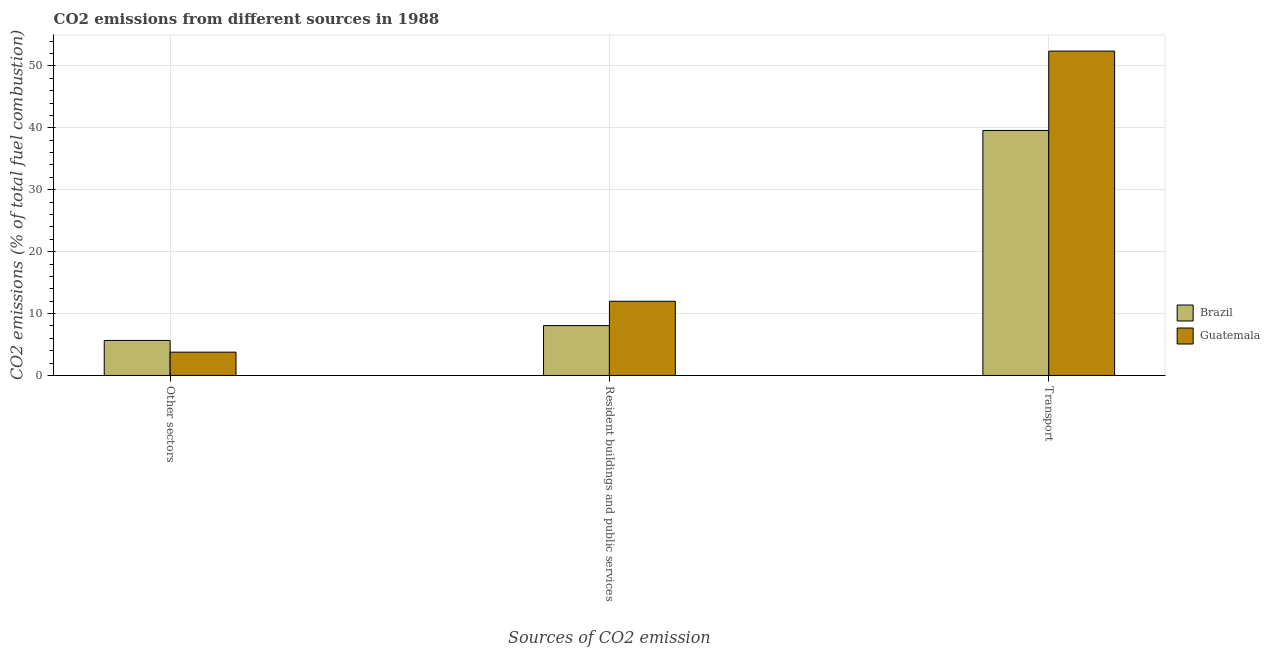How many different coloured bars are there?
Make the answer very short. 2. How many groups of bars are there?
Provide a short and direct response. 3. How many bars are there on the 2nd tick from the right?
Offer a terse response. 2. What is the label of the 2nd group of bars from the left?
Your response must be concise. Resident buildings and public services. What is the percentage of co2 emissions from other sectors in Guatemala?
Give a very brief answer. 3.77. Across all countries, what is the maximum percentage of co2 emissions from resident buildings and public services?
Offer a very short reply. 11.99. Across all countries, what is the minimum percentage of co2 emissions from transport?
Your response must be concise. 39.58. In which country was the percentage of co2 emissions from transport maximum?
Your answer should be compact. Guatemala. In which country was the percentage of co2 emissions from resident buildings and public services minimum?
Offer a very short reply. Brazil. What is the total percentage of co2 emissions from resident buildings and public services in the graph?
Ensure brevity in your answer.  20.05. What is the difference between the percentage of co2 emissions from other sectors in Brazil and that in Guatemala?
Offer a terse response. 1.89. What is the difference between the percentage of co2 emissions from other sectors in Brazil and the percentage of co2 emissions from transport in Guatemala?
Offer a terse response. -46.74. What is the average percentage of co2 emissions from transport per country?
Provide a succinct answer. 45.99. What is the difference between the percentage of co2 emissions from transport and percentage of co2 emissions from resident buildings and public services in Guatemala?
Your answer should be very brief. 40.41. In how many countries, is the percentage of co2 emissions from resident buildings and public services greater than 12 %?
Your response must be concise. 0. What is the ratio of the percentage of co2 emissions from transport in Guatemala to that in Brazil?
Your answer should be compact. 1.32. Is the difference between the percentage of co2 emissions from transport in Brazil and Guatemala greater than the difference between the percentage of co2 emissions from other sectors in Brazil and Guatemala?
Your answer should be compact. No. What is the difference between the highest and the second highest percentage of co2 emissions from resident buildings and public services?
Make the answer very short. 3.93. What is the difference between the highest and the lowest percentage of co2 emissions from other sectors?
Make the answer very short. 1.89. What does the 1st bar from the left in Other sectors represents?
Offer a very short reply. Brazil. What does the 1st bar from the right in Transport represents?
Offer a very short reply. Guatemala. How many bars are there?
Your answer should be compact. 6. Are all the bars in the graph horizontal?
Your answer should be very brief. No. How many countries are there in the graph?
Keep it short and to the point. 2. Are the values on the major ticks of Y-axis written in scientific E-notation?
Give a very brief answer. No. Does the graph contain grids?
Offer a terse response. Yes. What is the title of the graph?
Provide a short and direct response. CO2 emissions from different sources in 1988. Does "Seychelles" appear as one of the legend labels in the graph?
Provide a short and direct response. No. What is the label or title of the X-axis?
Make the answer very short. Sources of CO2 emission. What is the label or title of the Y-axis?
Your answer should be very brief. CO2 emissions (% of total fuel combustion). What is the CO2 emissions (% of total fuel combustion) in Brazil in Other sectors?
Give a very brief answer. 5.66. What is the CO2 emissions (% of total fuel combustion) of Guatemala in Other sectors?
Your response must be concise. 3.77. What is the CO2 emissions (% of total fuel combustion) of Brazil in Resident buildings and public services?
Make the answer very short. 8.06. What is the CO2 emissions (% of total fuel combustion) in Guatemala in Resident buildings and public services?
Your answer should be very brief. 11.99. What is the CO2 emissions (% of total fuel combustion) in Brazil in Transport?
Offer a very short reply. 39.58. What is the CO2 emissions (% of total fuel combustion) of Guatemala in Transport?
Offer a very short reply. 52.4. Across all Sources of CO2 emission, what is the maximum CO2 emissions (% of total fuel combustion) in Brazil?
Your answer should be very brief. 39.58. Across all Sources of CO2 emission, what is the maximum CO2 emissions (% of total fuel combustion) of Guatemala?
Provide a succinct answer. 52.4. Across all Sources of CO2 emission, what is the minimum CO2 emissions (% of total fuel combustion) of Brazil?
Offer a terse response. 5.66. Across all Sources of CO2 emission, what is the minimum CO2 emissions (% of total fuel combustion) of Guatemala?
Offer a very short reply. 3.77. What is the total CO2 emissions (% of total fuel combustion) of Brazil in the graph?
Your response must be concise. 53.3. What is the total CO2 emissions (% of total fuel combustion) in Guatemala in the graph?
Make the answer very short. 68.15. What is the difference between the CO2 emissions (% of total fuel combustion) of Brazil in Other sectors and that in Resident buildings and public services?
Keep it short and to the point. -2.4. What is the difference between the CO2 emissions (% of total fuel combustion) of Guatemala in Other sectors and that in Resident buildings and public services?
Your answer should be compact. -8.22. What is the difference between the CO2 emissions (% of total fuel combustion) of Brazil in Other sectors and that in Transport?
Your response must be concise. -33.92. What is the difference between the CO2 emissions (% of total fuel combustion) in Guatemala in Other sectors and that in Transport?
Offer a very short reply. -48.63. What is the difference between the CO2 emissions (% of total fuel combustion) in Brazil in Resident buildings and public services and that in Transport?
Make the answer very short. -31.52. What is the difference between the CO2 emissions (% of total fuel combustion) of Guatemala in Resident buildings and public services and that in Transport?
Make the answer very short. -40.41. What is the difference between the CO2 emissions (% of total fuel combustion) of Brazil in Other sectors and the CO2 emissions (% of total fuel combustion) of Guatemala in Resident buildings and public services?
Your response must be concise. -6.33. What is the difference between the CO2 emissions (% of total fuel combustion) in Brazil in Other sectors and the CO2 emissions (% of total fuel combustion) in Guatemala in Transport?
Give a very brief answer. -46.74. What is the difference between the CO2 emissions (% of total fuel combustion) in Brazil in Resident buildings and public services and the CO2 emissions (% of total fuel combustion) in Guatemala in Transport?
Give a very brief answer. -44.34. What is the average CO2 emissions (% of total fuel combustion) in Brazil per Sources of CO2 emission?
Your response must be concise. 17.77. What is the average CO2 emissions (% of total fuel combustion) in Guatemala per Sources of CO2 emission?
Your answer should be compact. 22.72. What is the difference between the CO2 emissions (% of total fuel combustion) of Brazil and CO2 emissions (% of total fuel combustion) of Guatemala in Other sectors?
Your answer should be very brief. 1.89. What is the difference between the CO2 emissions (% of total fuel combustion) in Brazil and CO2 emissions (% of total fuel combustion) in Guatemala in Resident buildings and public services?
Offer a very short reply. -3.93. What is the difference between the CO2 emissions (% of total fuel combustion) in Brazil and CO2 emissions (% of total fuel combustion) in Guatemala in Transport?
Provide a succinct answer. -12.82. What is the ratio of the CO2 emissions (% of total fuel combustion) in Brazil in Other sectors to that in Resident buildings and public services?
Your answer should be very brief. 0.7. What is the ratio of the CO2 emissions (% of total fuel combustion) in Guatemala in Other sectors to that in Resident buildings and public services?
Provide a succinct answer. 0.31. What is the ratio of the CO2 emissions (% of total fuel combustion) of Brazil in Other sectors to that in Transport?
Give a very brief answer. 0.14. What is the ratio of the CO2 emissions (% of total fuel combustion) of Guatemala in Other sectors to that in Transport?
Offer a terse response. 0.07. What is the ratio of the CO2 emissions (% of total fuel combustion) of Brazil in Resident buildings and public services to that in Transport?
Offer a very short reply. 0.2. What is the ratio of the CO2 emissions (% of total fuel combustion) in Guatemala in Resident buildings and public services to that in Transport?
Give a very brief answer. 0.23. What is the difference between the highest and the second highest CO2 emissions (% of total fuel combustion) of Brazil?
Make the answer very short. 31.52. What is the difference between the highest and the second highest CO2 emissions (% of total fuel combustion) in Guatemala?
Provide a short and direct response. 40.41. What is the difference between the highest and the lowest CO2 emissions (% of total fuel combustion) in Brazil?
Keep it short and to the point. 33.92. What is the difference between the highest and the lowest CO2 emissions (% of total fuel combustion) of Guatemala?
Your answer should be very brief. 48.63. 